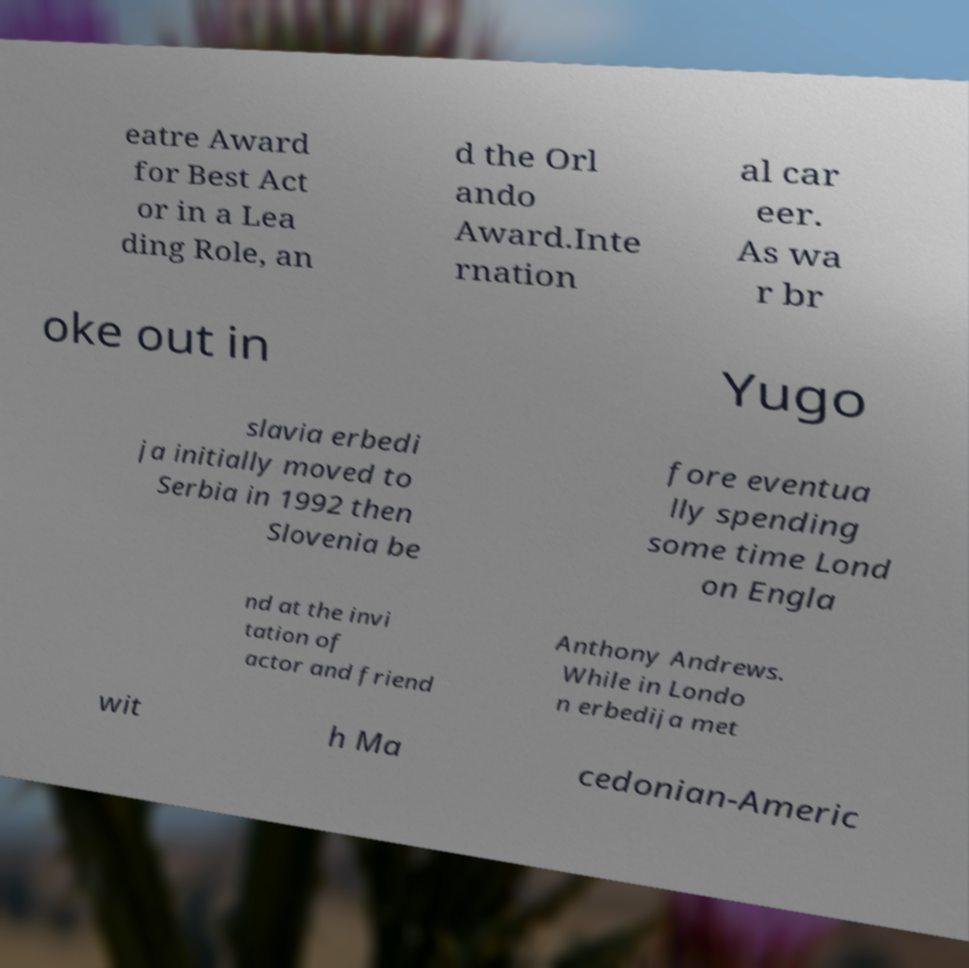What messages or text are displayed in this image? I need them in a readable, typed format. eatre Award for Best Act or in a Lea ding Role, an d the Orl ando Award.Inte rnation al car eer. As wa r br oke out in Yugo slavia erbedi ja initially moved to Serbia in 1992 then Slovenia be fore eventua lly spending some time Lond on Engla nd at the invi tation of actor and friend Anthony Andrews. While in Londo n erbedija met wit h Ma cedonian-Americ 